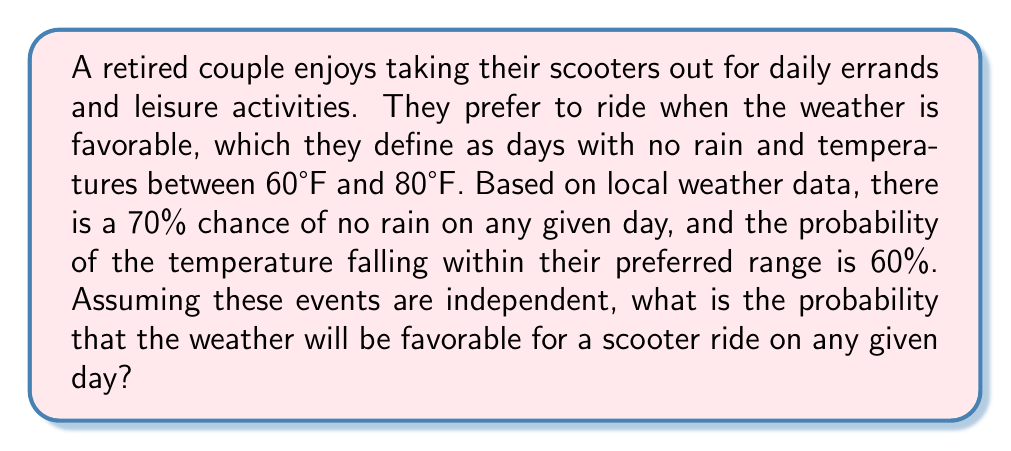Can you solve this math problem? To solve this problem, we need to use the concept of independent events and their probabilities. We'll follow these steps:

1. Identify the two independent events:
   Event A: No rain (probability = 70% = 0.70)
   Event B: Temperature between 60°F and 80°F (probability = 60% = 0.60)

2. For the weather to be favorable, both events must occur simultaneously. Since the events are independent, we can use the multiplication rule of probability.

3. The probability of both events occurring is the product of their individual probabilities:

   $$P(\text{Favorable Weather}) = P(A \cap B) = P(A) \times P(B)$$

4. Substitute the given probabilities:

   $$P(\text{Favorable Weather}) = 0.70 \times 0.60$$

5. Calculate the result:

   $$P(\text{Favorable Weather}) = 0.42$$

6. Convert the decimal to a percentage:

   $$0.42 \times 100\% = 42\%$$

Therefore, the probability of encountering favorable weather conditions for a scooter ride on any given day is 42%.
Answer: 42% 